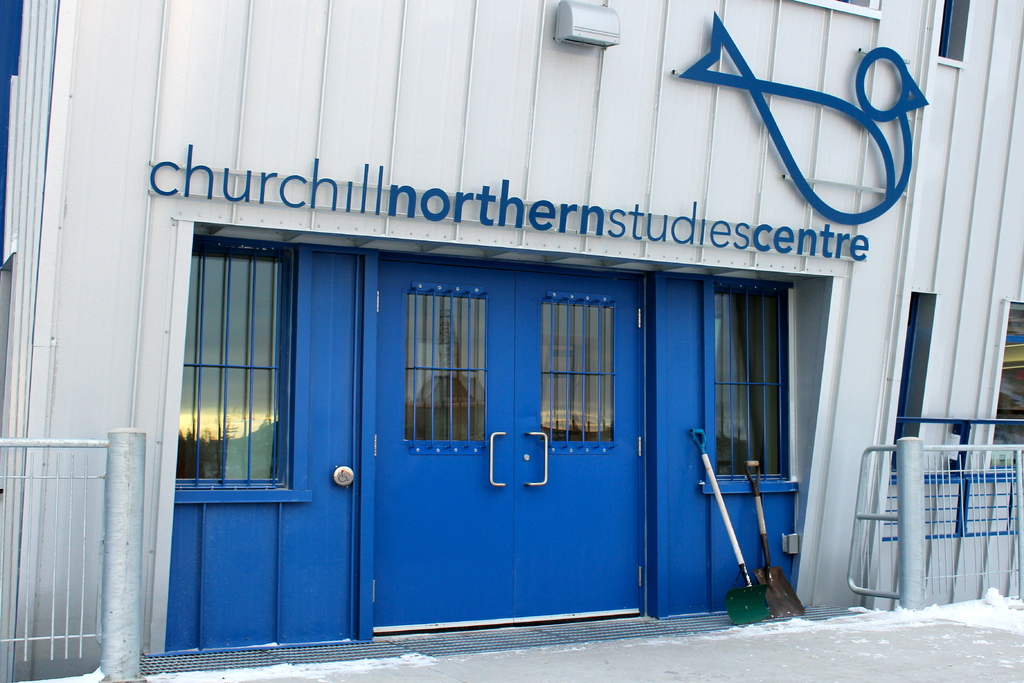Can you describe the main features of this image for me? The image captures the entrance to the Churchill Northern Studies Centre, a research facility located in Manitoba, Canada. The entrance features a set of blue double doors, which are the main focal point of the image. Adjacent to the doors, a shovel is propped up against the wall, possibly used for clearing the snow that blankets the ground in front of the building. The building itself is painted white and topped with a gray roof, a color scheme that blends with the snowy surroundings. Above the doors, a sign displays the facility's name and logo, indicating its identity as the Churchill Northern Studies Centre. The text "churchillnorthernstudiescentre" is prominently visible, reinforcing the identity of the building. The image conveys a sense of the facility's purpose and location, providing a glimpse into the world of scientific research in the harsh yet beautiful environment of Manitoba. 